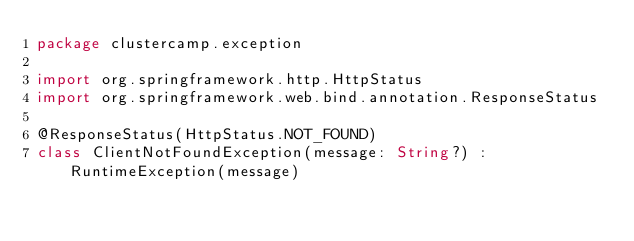<code> <loc_0><loc_0><loc_500><loc_500><_Kotlin_>package clustercamp.exception

import org.springframework.http.HttpStatus
import org.springframework.web.bind.annotation.ResponseStatus

@ResponseStatus(HttpStatus.NOT_FOUND)
class ClientNotFoundException(message: String?) : RuntimeException(message)</code> 